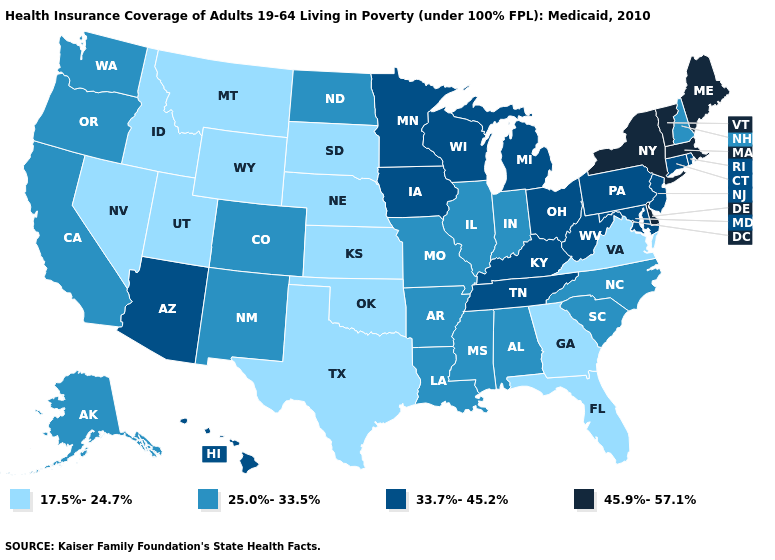What is the lowest value in the USA?
Give a very brief answer. 17.5%-24.7%. Among the states that border North Dakota , which have the lowest value?
Be succinct. Montana, South Dakota. Which states have the highest value in the USA?
Be succinct. Delaware, Maine, Massachusetts, New York, Vermont. Name the states that have a value in the range 17.5%-24.7%?
Give a very brief answer. Florida, Georgia, Idaho, Kansas, Montana, Nebraska, Nevada, Oklahoma, South Dakota, Texas, Utah, Virginia, Wyoming. Name the states that have a value in the range 45.9%-57.1%?
Short answer required. Delaware, Maine, Massachusetts, New York, Vermont. Name the states that have a value in the range 17.5%-24.7%?
Concise answer only. Florida, Georgia, Idaho, Kansas, Montana, Nebraska, Nevada, Oklahoma, South Dakota, Texas, Utah, Virginia, Wyoming. Name the states that have a value in the range 33.7%-45.2%?
Answer briefly. Arizona, Connecticut, Hawaii, Iowa, Kentucky, Maryland, Michigan, Minnesota, New Jersey, Ohio, Pennsylvania, Rhode Island, Tennessee, West Virginia, Wisconsin. What is the value of Texas?
Be succinct. 17.5%-24.7%. Name the states that have a value in the range 17.5%-24.7%?
Be succinct. Florida, Georgia, Idaho, Kansas, Montana, Nebraska, Nevada, Oklahoma, South Dakota, Texas, Utah, Virginia, Wyoming. Which states have the lowest value in the USA?
Answer briefly. Florida, Georgia, Idaho, Kansas, Montana, Nebraska, Nevada, Oklahoma, South Dakota, Texas, Utah, Virginia, Wyoming. What is the value of Montana?
Write a very short answer. 17.5%-24.7%. Among the states that border Arizona , which have the highest value?
Short answer required. California, Colorado, New Mexico. What is the lowest value in states that border Wisconsin?
Give a very brief answer. 25.0%-33.5%. What is the value of Illinois?
Short answer required. 25.0%-33.5%. Does Oregon have the highest value in the USA?
Be succinct. No. 